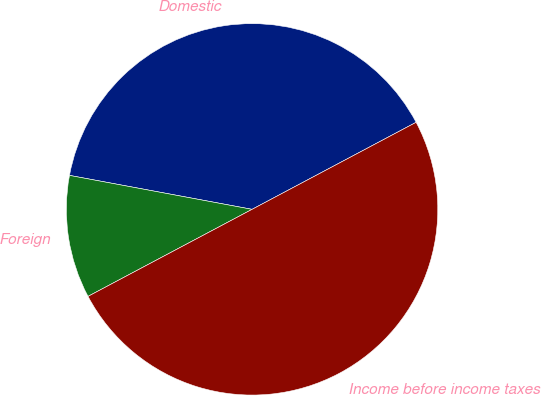<chart> <loc_0><loc_0><loc_500><loc_500><pie_chart><fcel>Domestic<fcel>Foreign<fcel>Income before income taxes<nl><fcel>39.31%<fcel>10.69%<fcel>50.0%<nl></chart> 